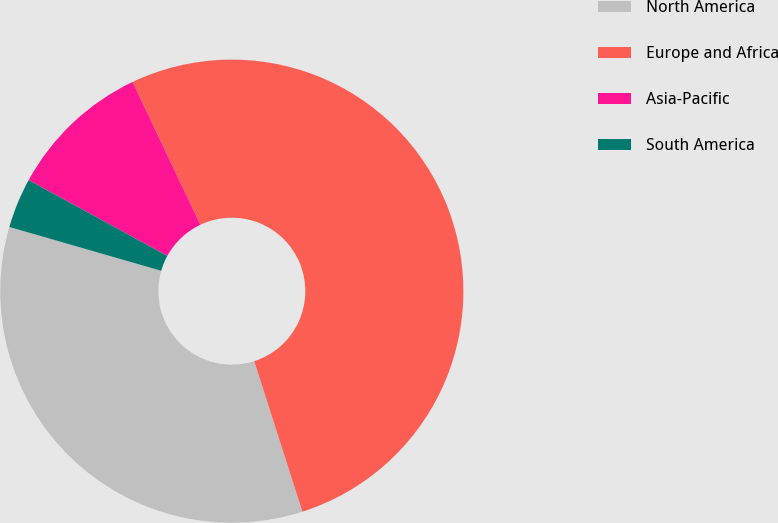Convert chart to OTSL. <chart><loc_0><loc_0><loc_500><loc_500><pie_chart><fcel>North America<fcel>Europe and Africa<fcel>Asia-Pacific<fcel>South America<nl><fcel>34.4%<fcel>52.12%<fcel>9.99%<fcel>3.49%<nl></chart> 